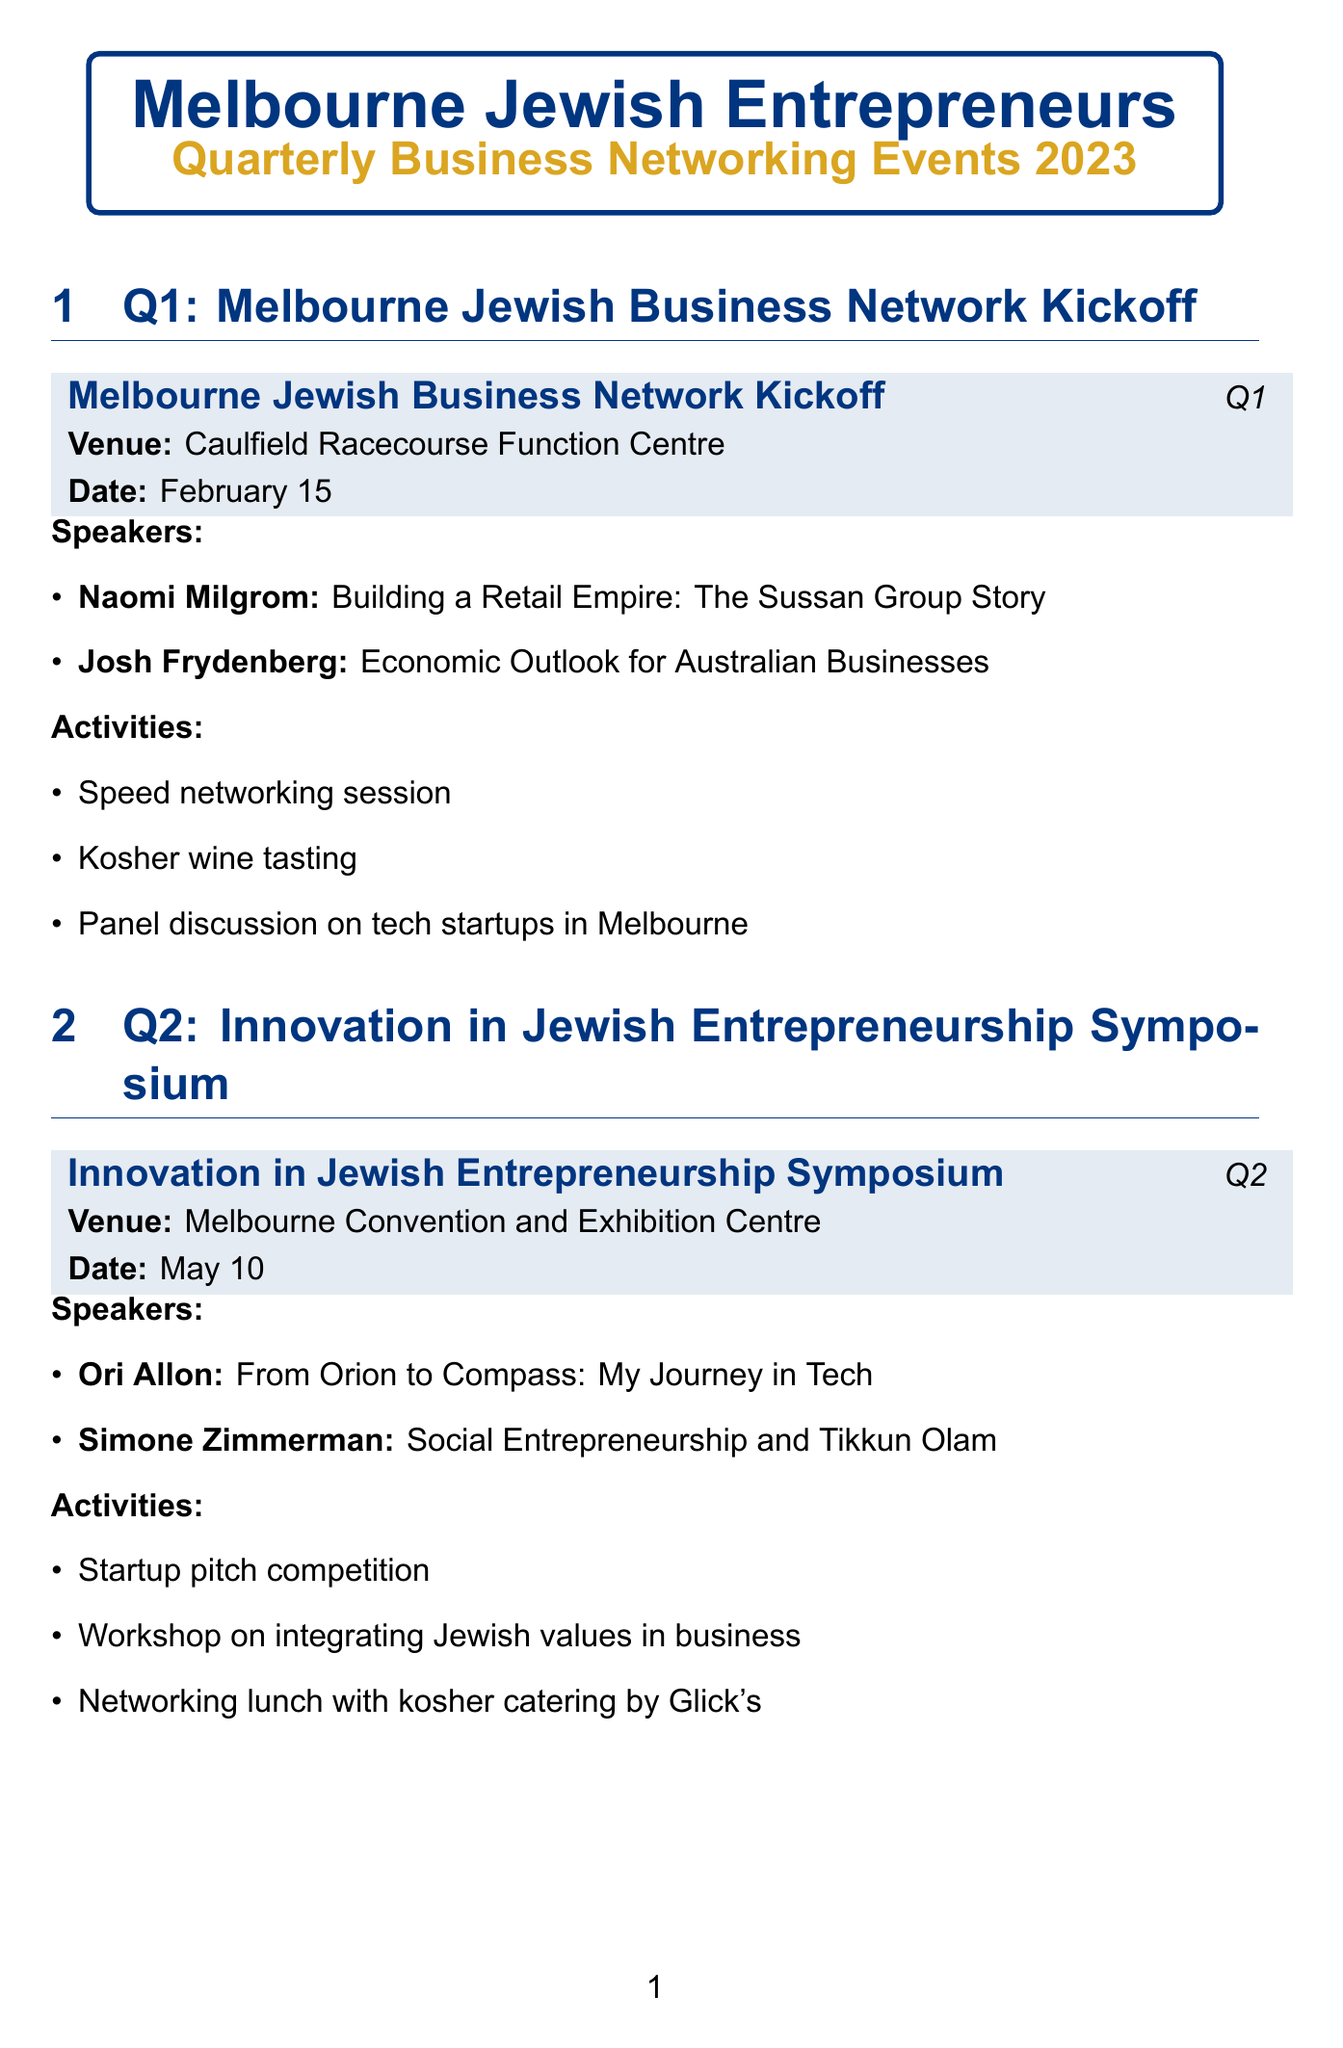What is the date of the Q4 event? The Q4 event is the "End-of-Year Jewish Entrepreneurs Gala," which occurs on November 30.
Answer: November 30 Who is the speaker discussing economic outlook at the Q1 event? In the Q1 event, Josh Frydenberg is the speaker discussing the economic outlook.
Answer: Josh Frydenberg What venue is the Q2 symposium held at? The Q2 event, "Innovation in Jewish Entrepreneurship Symposium," is held at the Melbourne Convention and Exhibition Centre.
Answer: Melbourne Convention and Exhibition Centre How many speakers are featured in the Q3 event? The Q3 event includes two speakers, Solomon Lew and Deborah Cheetham.
Answer: 2 What type of activity is included in Q1? The Q1 event includes a speed networking session as one of its activities.
Answer: Speed networking session What recurring activity focuses on business ethics? The recurring activity that focuses on business ethics is the Torah and Business Ethics study group.
Answer: Torah and Business Ethics study group What is the total number of sponsorship partners listed? There are four sponsors listed in the document: Commonwealth Bank of Australia, Gandel Group, Pratt Foundation, and Jagen Pty Ltd.
Answer: 4 Which Q3 speaker focuses on entrepreneurship in the arts? Deborah Cheetham is the speaker at the Q3 event focusing on entrepreneurship in the arts.
Answer: Deborah Cheetham What is the theme of the Q2 event? The theme of the Q2 event is "Innovation in Jewish Entrepreneurship."
Answer: Innovation in Jewish Entrepreneurship 